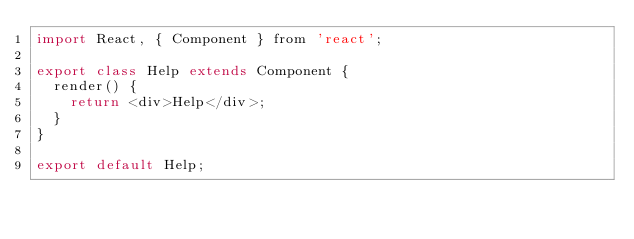<code> <loc_0><loc_0><loc_500><loc_500><_JavaScript_>import React, { Component } from 'react';

export class Help extends Component {
  render() {
    return <div>Help</div>;
  }
}

export default Help;
</code> 